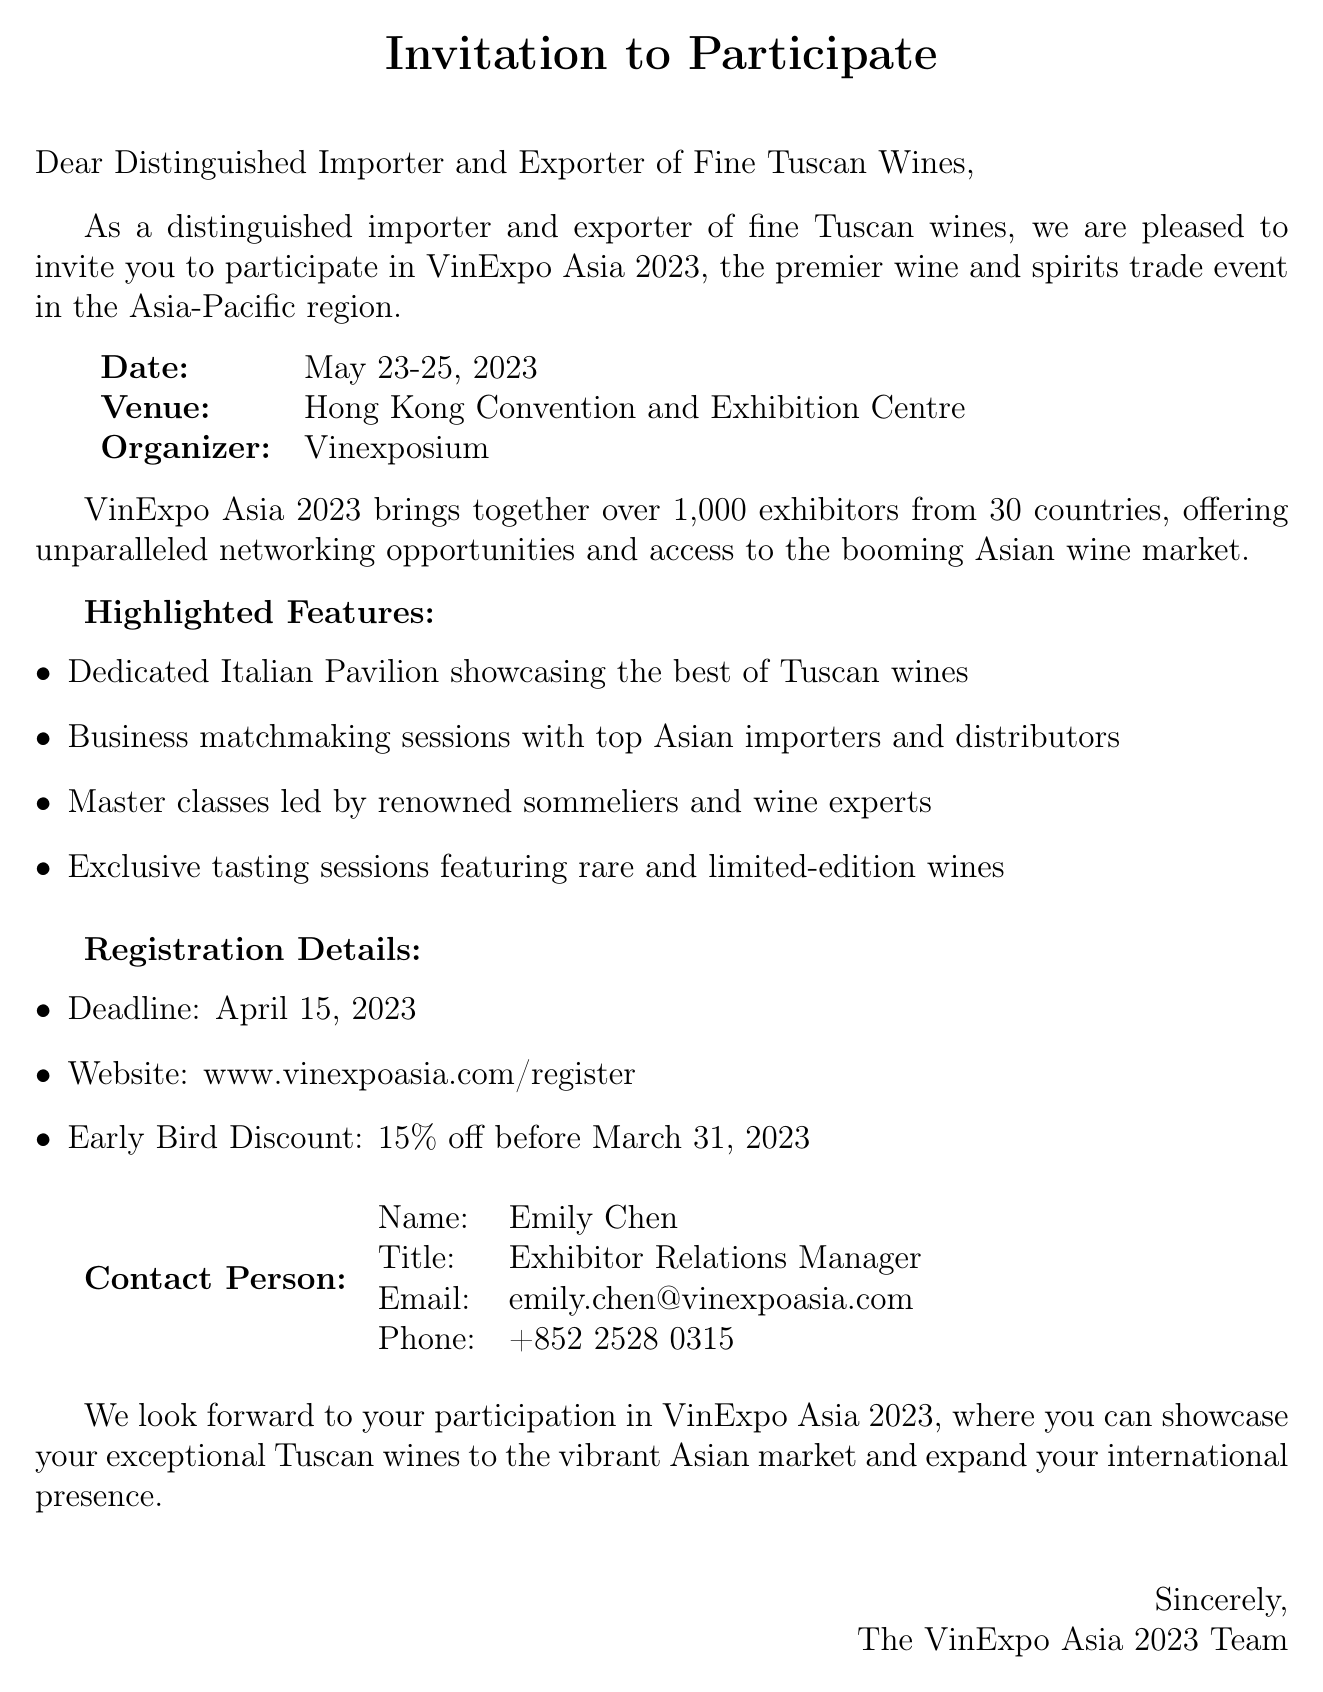What is the event name? The event name is stated at the beginning of the invitation.
Answer: VinExpo Asia 2023 What are the event dates? The dates of the event are listed in the event details section.
Answer: May 23-25, 2023 Where is the venue located? The venue is mentioned shortly after the event name.
Answer: Hong Kong Convention and Exhibition Centre Who is the organizer of the event? The organizer's name is provided in the document.
Answer: Vinexposium What is the registration deadline? The deadline for registration is specified in the registration details section.
Answer: April 15, 2023 What discount is available for early registration? The discount information is included in the registration details.
Answer: 15% off before March 31, 2023 What is the primary aim of the event? The main purpose of the event can be inferred from the description of the event.
Answer: Networking opportunities and access to the Asian wine market Who should be contacted for more information? The contact person's name and details are provided at the end of the invitation.
Answer: Emily Chen What types of special sessions are highlighted? The highlighted sessions are listed in the features section.
Answer: Master classes and exclusive tasting sessions 